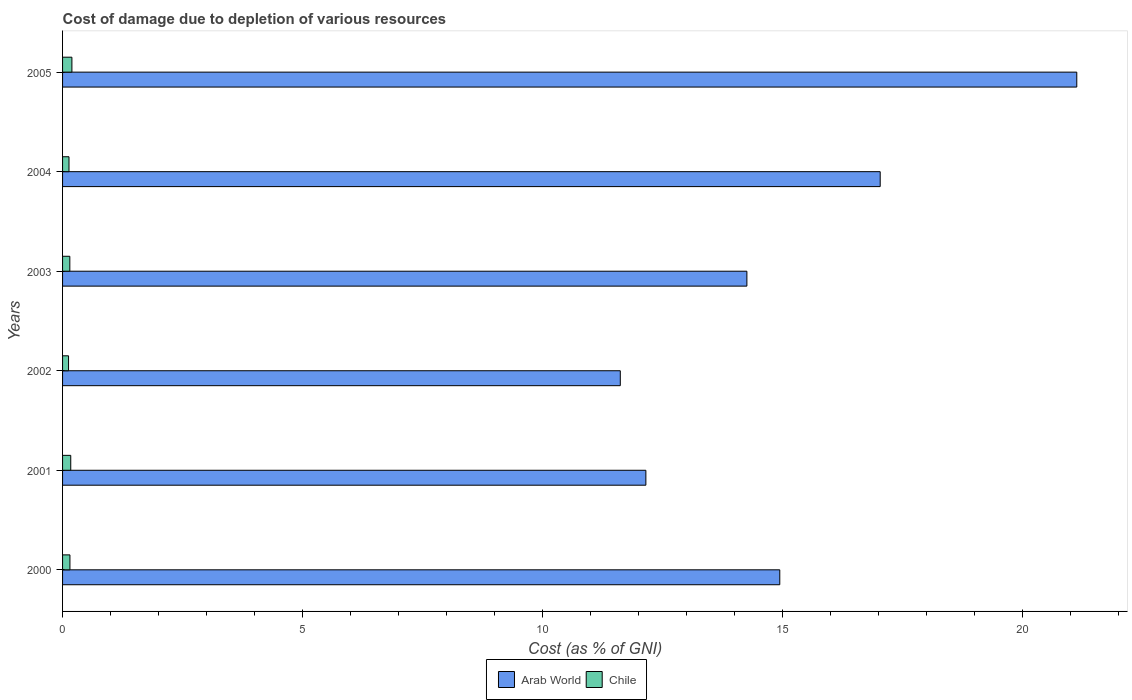How many different coloured bars are there?
Provide a succinct answer. 2. How many bars are there on the 5th tick from the bottom?
Keep it short and to the point. 2. What is the label of the 4th group of bars from the top?
Keep it short and to the point. 2002. What is the cost of damage caused due to the depletion of various resources in Chile in 2005?
Offer a very short reply. 0.19. Across all years, what is the maximum cost of damage caused due to the depletion of various resources in Arab World?
Keep it short and to the point. 21.14. Across all years, what is the minimum cost of damage caused due to the depletion of various resources in Chile?
Your answer should be compact. 0.12. In which year was the cost of damage caused due to the depletion of various resources in Chile maximum?
Ensure brevity in your answer.  2005. What is the total cost of damage caused due to the depletion of various resources in Arab World in the graph?
Offer a terse response. 91.18. What is the difference between the cost of damage caused due to the depletion of various resources in Chile in 2000 and that in 2001?
Provide a short and direct response. -0.02. What is the difference between the cost of damage caused due to the depletion of various resources in Arab World in 2000 and the cost of damage caused due to the depletion of various resources in Chile in 2003?
Give a very brief answer. 14.8. What is the average cost of damage caused due to the depletion of various resources in Arab World per year?
Make the answer very short. 15.2. In the year 2003, what is the difference between the cost of damage caused due to the depletion of various resources in Arab World and cost of damage caused due to the depletion of various resources in Chile?
Offer a terse response. 14.11. In how many years, is the cost of damage caused due to the depletion of various resources in Chile greater than 18 %?
Offer a very short reply. 0. What is the ratio of the cost of damage caused due to the depletion of various resources in Arab World in 2001 to that in 2003?
Offer a terse response. 0.85. What is the difference between the highest and the second highest cost of damage caused due to the depletion of various resources in Chile?
Provide a short and direct response. 0.02. What is the difference between the highest and the lowest cost of damage caused due to the depletion of various resources in Arab World?
Make the answer very short. 9.51. In how many years, is the cost of damage caused due to the depletion of various resources in Chile greater than the average cost of damage caused due to the depletion of various resources in Chile taken over all years?
Keep it short and to the point. 2. Is the sum of the cost of damage caused due to the depletion of various resources in Chile in 2004 and 2005 greater than the maximum cost of damage caused due to the depletion of various resources in Arab World across all years?
Provide a succinct answer. No. What does the 1st bar from the top in 2005 represents?
Your response must be concise. Chile. Does the graph contain any zero values?
Provide a short and direct response. No. Does the graph contain grids?
Provide a succinct answer. No. What is the title of the graph?
Ensure brevity in your answer.  Cost of damage due to depletion of various resources. Does "Andorra" appear as one of the legend labels in the graph?
Your answer should be very brief. No. What is the label or title of the X-axis?
Provide a short and direct response. Cost (as % of GNI). What is the label or title of the Y-axis?
Your answer should be very brief. Years. What is the Cost (as % of GNI) in Arab World in 2000?
Offer a terse response. 14.95. What is the Cost (as % of GNI) in Chile in 2000?
Your answer should be compact. 0.15. What is the Cost (as % of GNI) of Arab World in 2001?
Your response must be concise. 12.16. What is the Cost (as % of GNI) of Chile in 2001?
Offer a very short reply. 0.17. What is the Cost (as % of GNI) in Arab World in 2002?
Give a very brief answer. 11.63. What is the Cost (as % of GNI) in Chile in 2002?
Make the answer very short. 0.12. What is the Cost (as % of GNI) in Arab World in 2003?
Your response must be concise. 14.26. What is the Cost (as % of GNI) of Chile in 2003?
Offer a terse response. 0.15. What is the Cost (as % of GNI) of Arab World in 2004?
Provide a short and direct response. 17.04. What is the Cost (as % of GNI) in Chile in 2004?
Ensure brevity in your answer.  0.13. What is the Cost (as % of GNI) of Arab World in 2005?
Give a very brief answer. 21.14. What is the Cost (as % of GNI) in Chile in 2005?
Give a very brief answer. 0.19. Across all years, what is the maximum Cost (as % of GNI) in Arab World?
Your answer should be very brief. 21.14. Across all years, what is the maximum Cost (as % of GNI) of Chile?
Give a very brief answer. 0.19. Across all years, what is the minimum Cost (as % of GNI) in Arab World?
Offer a terse response. 11.63. Across all years, what is the minimum Cost (as % of GNI) in Chile?
Your answer should be very brief. 0.12. What is the total Cost (as % of GNI) in Arab World in the graph?
Your answer should be compact. 91.18. What is the total Cost (as % of GNI) of Chile in the graph?
Give a very brief answer. 0.93. What is the difference between the Cost (as % of GNI) of Arab World in 2000 and that in 2001?
Keep it short and to the point. 2.79. What is the difference between the Cost (as % of GNI) in Chile in 2000 and that in 2001?
Your response must be concise. -0.02. What is the difference between the Cost (as % of GNI) in Arab World in 2000 and that in 2002?
Your response must be concise. 3.32. What is the difference between the Cost (as % of GNI) of Chile in 2000 and that in 2002?
Keep it short and to the point. 0.03. What is the difference between the Cost (as % of GNI) of Arab World in 2000 and that in 2003?
Your response must be concise. 0.69. What is the difference between the Cost (as % of GNI) in Chile in 2000 and that in 2003?
Your response must be concise. 0. What is the difference between the Cost (as % of GNI) of Arab World in 2000 and that in 2004?
Keep it short and to the point. -2.09. What is the difference between the Cost (as % of GNI) in Chile in 2000 and that in 2004?
Your answer should be compact. 0.02. What is the difference between the Cost (as % of GNI) of Arab World in 2000 and that in 2005?
Provide a short and direct response. -6.19. What is the difference between the Cost (as % of GNI) of Chile in 2000 and that in 2005?
Your answer should be compact. -0.04. What is the difference between the Cost (as % of GNI) in Arab World in 2001 and that in 2002?
Offer a terse response. 0.53. What is the difference between the Cost (as % of GNI) in Chile in 2001 and that in 2002?
Offer a terse response. 0.05. What is the difference between the Cost (as % of GNI) in Arab World in 2001 and that in 2003?
Make the answer very short. -2.11. What is the difference between the Cost (as % of GNI) in Chile in 2001 and that in 2003?
Provide a short and direct response. 0.02. What is the difference between the Cost (as % of GNI) in Arab World in 2001 and that in 2004?
Give a very brief answer. -4.88. What is the difference between the Cost (as % of GNI) in Chile in 2001 and that in 2004?
Offer a terse response. 0.04. What is the difference between the Cost (as % of GNI) in Arab World in 2001 and that in 2005?
Offer a very short reply. -8.98. What is the difference between the Cost (as % of GNI) in Chile in 2001 and that in 2005?
Your answer should be compact. -0.02. What is the difference between the Cost (as % of GNI) in Arab World in 2002 and that in 2003?
Offer a very short reply. -2.64. What is the difference between the Cost (as % of GNI) in Chile in 2002 and that in 2003?
Your response must be concise. -0.03. What is the difference between the Cost (as % of GNI) in Arab World in 2002 and that in 2004?
Your answer should be compact. -5.42. What is the difference between the Cost (as % of GNI) of Chile in 2002 and that in 2004?
Offer a very short reply. -0.01. What is the difference between the Cost (as % of GNI) in Arab World in 2002 and that in 2005?
Make the answer very short. -9.51. What is the difference between the Cost (as % of GNI) of Chile in 2002 and that in 2005?
Make the answer very short. -0.07. What is the difference between the Cost (as % of GNI) in Arab World in 2003 and that in 2004?
Your answer should be compact. -2.78. What is the difference between the Cost (as % of GNI) of Chile in 2003 and that in 2004?
Give a very brief answer. 0.02. What is the difference between the Cost (as % of GNI) in Arab World in 2003 and that in 2005?
Offer a very short reply. -6.88. What is the difference between the Cost (as % of GNI) of Chile in 2003 and that in 2005?
Offer a terse response. -0.04. What is the difference between the Cost (as % of GNI) of Arab World in 2004 and that in 2005?
Keep it short and to the point. -4.1. What is the difference between the Cost (as % of GNI) of Chile in 2004 and that in 2005?
Offer a very short reply. -0.06. What is the difference between the Cost (as % of GNI) of Arab World in 2000 and the Cost (as % of GNI) of Chile in 2001?
Offer a very short reply. 14.78. What is the difference between the Cost (as % of GNI) of Arab World in 2000 and the Cost (as % of GNI) of Chile in 2002?
Your answer should be very brief. 14.82. What is the difference between the Cost (as % of GNI) of Arab World in 2000 and the Cost (as % of GNI) of Chile in 2003?
Make the answer very short. 14.8. What is the difference between the Cost (as % of GNI) of Arab World in 2000 and the Cost (as % of GNI) of Chile in 2004?
Offer a very short reply. 14.82. What is the difference between the Cost (as % of GNI) of Arab World in 2000 and the Cost (as % of GNI) of Chile in 2005?
Make the answer very short. 14.75. What is the difference between the Cost (as % of GNI) of Arab World in 2001 and the Cost (as % of GNI) of Chile in 2002?
Provide a succinct answer. 12.03. What is the difference between the Cost (as % of GNI) of Arab World in 2001 and the Cost (as % of GNI) of Chile in 2003?
Your response must be concise. 12.01. What is the difference between the Cost (as % of GNI) of Arab World in 2001 and the Cost (as % of GNI) of Chile in 2004?
Offer a terse response. 12.02. What is the difference between the Cost (as % of GNI) in Arab World in 2001 and the Cost (as % of GNI) in Chile in 2005?
Offer a very short reply. 11.96. What is the difference between the Cost (as % of GNI) in Arab World in 2002 and the Cost (as % of GNI) in Chile in 2003?
Your answer should be very brief. 11.47. What is the difference between the Cost (as % of GNI) of Arab World in 2002 and the Cost (as % of GNI) of Chile in 2004?
Keep it short and to the point. 11.49. What is the difference between the Cost (as % of GNI) in Arab World in 2002 and the Cost (as % of GNI) in Chile in 2005?
Provide a short and direct response. 11.43. What is the difference between the Cost (as % of GNI) of Arab World in 2003 and the Cost (as % of GNI) of Chile in 2004?
Your answer should be very brief. 14.13. What is the difference between the Cost (as % of GNI) in Arab World in 2003 and the Cost (as % of GNI) in Chile in 2005?
Ensure brevity in your answer.  14.07. What is the difference between the Cost (as % of GNI) of Arab World in 2004 and the Cost (as % of GNI) of Chile in 2005?
Make the answer very short. 16.85. What is the average Cost (as % of GNI) of Arab World per year?
Make the answer very short. 15.2. What is the average Cost (as % of GNI) of Chile per year?
Give a very brief answer. 0.15. In the year 2000, what is the difference between the Cost (as % of GNI) in Arab World and Cost (as % of GNI) in Chile?
Keep it short and to the point. 14.8. In the year 2001, what is the difference between the Cost (as % of GNI) of Arab World and Cost (as % of GNI) of Chile?
Provide a succinct answer. 11.99. In the year 2002, what is the difference between the Cost (as % of GNI) in Arab World and Cost (as % of GNI) in Chile?
Offer a terse response. 11.5. In the year 2003, what is the difference between the Cost (as % of GNI) of Arab World and Cost (as % of GNI) of Chile?
Offer a very short reply. 14.11. In the year 2004, what is the difference between the Cost (as % of GNI) in Arab World and Cost (as % of GNI) in Chile?
Keep it short and to the point. 16.91. In the year 2005, what is the difference between the Cost (as % of GNI) in Arab World and Cost (as % of GNI) in Chile?
Your response must be concise. 20.95. What is the ratio of the Cost (as % of GNI) in Arab World in 2000 to that in 2001?
Make the answer very short. 1.23. What is the ratio of the Cost (as % of GNI) in Chile in 2000 to that in 2001?
Your response must be concise. 0.9. What is the ratio of the Cost (as % of GNI) in Arab World in 2000 to that in 2002?
Offer a terse response. 1.29. What is the ratio of the Cost (as % of GNI) of Chile in 2000 to that in 2002?
Provide a short and direct response. 1.23. What is the ratio of the Cost (as % of GNI) in Arab World in 2000 to that in 2003?
Your answer should be very brief. 1.05. What is the ratio of the Cost (as % of GNI) of Chile in 2000 to that in 2003?
Keep it short and to the point. 1.01. What is the ratio of the Cost (as % of GNI) in Arab World in 2000 to that in 2004?
Offer a very short reply. 0.88. What is the ratio of the Cost (as % of GNI) of Chile in 2000 to that in 2004?
Make the answer very short. 1.15. What is the ratio of the Cost (as % of GNI) in Arab World in 2000 to that in 2005?
Give a very brief answer. 0.71. What is the ratio of the Cost (as % of GNI) of Chile in 2000 to that in 2005?
Your response must be concise. 0.79. What is the ratio of the Cost (as % of GNI) of Arab World in 2001 to that in 2002?
Your response must be concise. 1.05. What is the ratio of the Cost (as % of GNI) in Chile in 2001 to that in 2002?
Your answer should be compact. 1.37. What is the ratio of the Cost (as % of GNI) of Arab World in 2001 to that in 2003?
Provide a short and direct response. 0.85. What is the ratio of the Cost (as % of GNI) in Chile in 2001 to that in 2003?
Make the answer very short. 1.13. What is the ratio of the Cost (as % of GNI) in Arab World in 2001 to that in 2004?
Offer a terse response. 0.71. What is the ratio of the Cost (as % of GNI) of Chile in 2001 to that in 2004?
Offer a terse response. 1.27. What is the ratio of the Cost (as % of GNI) of Arab World in 2001 to that in 2005?
Provide a short and direct response. 0.58. What is the ratio of the Cost (as % of GNI) in Chile in 2001 to that in 2005?
Provide a succinct answer. 0.88. What is the ratio of the Cost (as % of GNI) of Arab World in 2002 to that in 2003?
Give a very brief answer. 0.81. What is the ratio of the Cost (as % of GNI) in Chile in 2002 to that in 2003?
Keep it short and to the point. 0.82. What is the ratio of the Cost (as % of GNI) of Arab World in 2002 to that in 2004?
Ensure brevity in your answer.  0.68. What is the ratio of the Cost (as % of GNI) in Chile in 2002 to that in 2004?
Give a very brief answer. 0.93. What is the ratio of the Cost (as % of GNI) in Arab World in 2002 to that in 2005?
Offer a terse response. 0.55. What is the ratio of the Cost (as % of GNI) in Chile in 2002 to that in 2005?
Your answer should be very brief. 0.64. What is the ratio of the Cost (as % of GNI) of Arab World in 2003 to that in 2004?
Offer a very short reply. 0.84. What is the ratio of the Cost (as % of GNI) of Chile in 2003 to that in 2004?
Provide a succinct answer. 1.13. What is the ratio of the Cost (as % of GNI) of Arab World in 2003 to that in 2005?
Your answer should be very brief. 0.67. What is the ratio of the Cost (as % of GNI) in Chile in 2003 to that in 2005?
Provide a short and direct response. 0.78. What is the ratio of the Cost (as % of GNI) in Arab World in 2004 to that in 2005?
Provide a short and direct response. 0.81. What is the ratio of the Cost (as % of GNI) in Chile in 2004 to that in 2005?
Keep it short and to the point. 0.69. What is the difference between the highest and the second highest Cost (as % of GNI) of Arab World?
Provide a short and direct response. 4.1. What is the difference between the highest and the second highest Cost (as % of GNI) in Chile?
Your answer should be compact. 0.02. What is the difference between the highest and the lowest Cost (as % of GNI) of Arab World?
Offer a very short reply. 9.51. What is the difference between the highest and the lowest Cost (as % of GNI) in Chile?
Your answer should be compact. 0.07. 